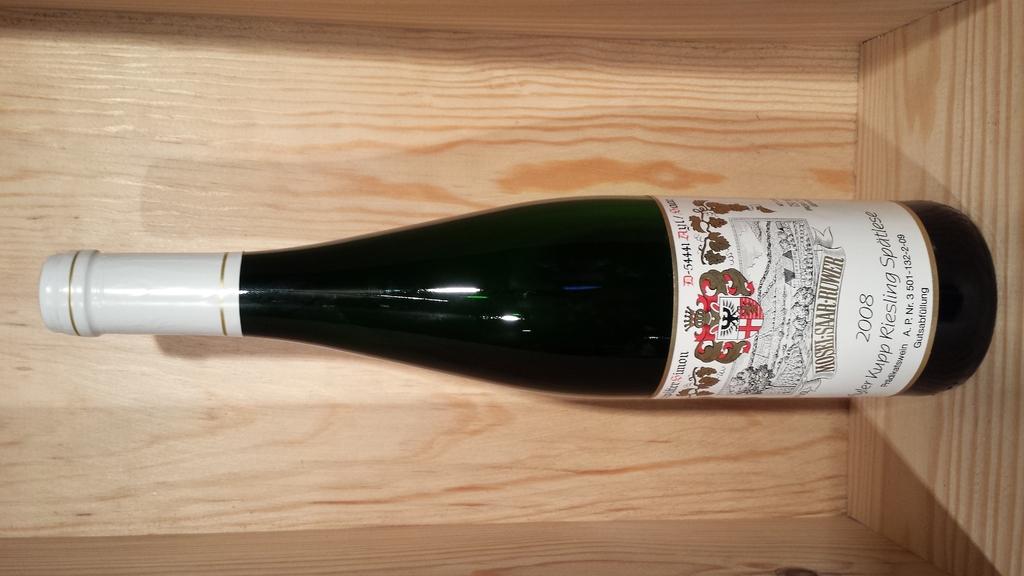What year is on the bottle?
Your answer should be very brief. 2008. 